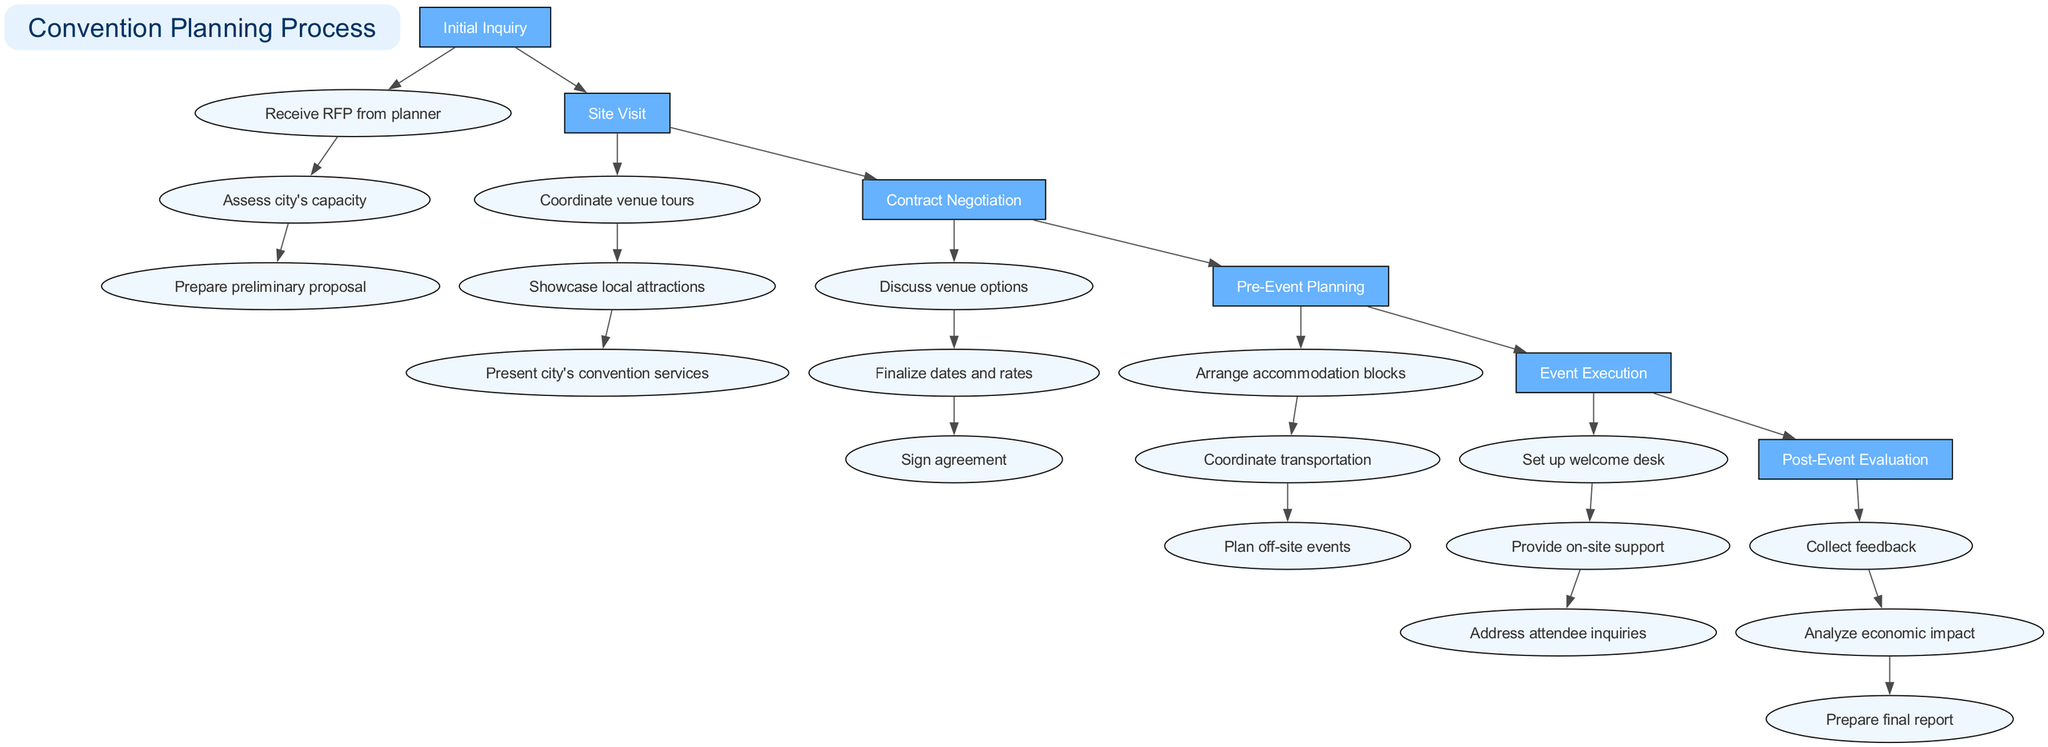What is the first stage in the convention planning process? The first stage listed in the diagram is "Initial Inquiry."
Answer: Initial Inquiry How many steps are there in the "Event Execution" stage? There are three steps detailed under the "Event Execution" stage.
Answer: 3 Which stage follows "Contract Negotiation"? The stage that follows "Contract Negotiation" is "Pre-Event Planning."
Answer: Pre-Event Planning What is the last step in the "Post-Event Evaluation" stage? The last step mentioned in the "Post-Event Evaluation" stage is "Prepare final report."
Answer: Prepare final report How many total stages are presented in the diagram? The diagram presents a total of six stages in the convention planning process.
Answer: 6 Which step comes after "Coordinate venue tours"? The step that comes after "Coordinate venue tours" is "Showcase local attractions."
Answer: Showcase local attractions What color represents the stages in the diagram? The stages are represented in a filled box with the color "#66B2FF."
Answer: #66B2FF Which step is associated with attendee support during the event? The step associated with attendee support during the event is "Provide on-site support."
Answer: Provide on-site support What type of node shape is used for the steps in each stage? The node shape used for the steps is an ellipse.
Answer: Ellipse 